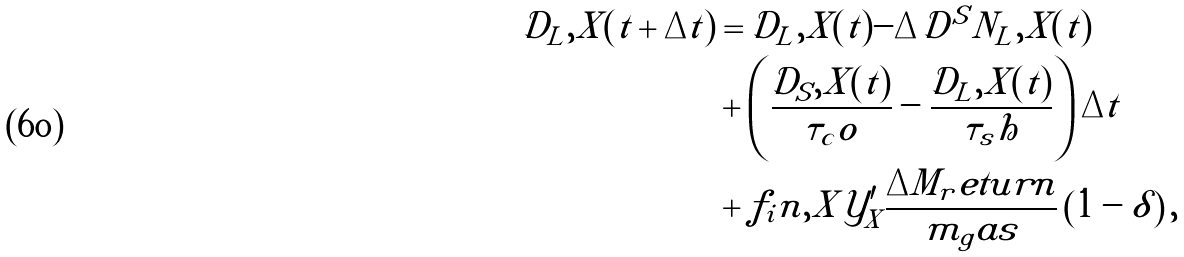<formula> <loc_0><loc_0><loc_500><loc_500>\mathcal { D } _ { L } , X ( t + \Delta t ) & = \mathcal { D } _ { L } , X ( t ) - \Delta \mathcal { D } ^ { S } N _ { L } , X ( t ) \\ & + \left ( \frac { \mathcal { D } _ { S } , X ( t ) } { \tau _ { c } o } - \frac { \mathcal { D } _ { L } , X ( t ) } { \tau _ { s } h } \right ) \Delta t \\ & + f _ { i } n , X \mathcal { Y } ^ { \prime } _ { X } \frac { \Delta M _ { r } e t u r n } { m _ { g } a s } \left ( 1 - \delta \right ) , \\</formula> 